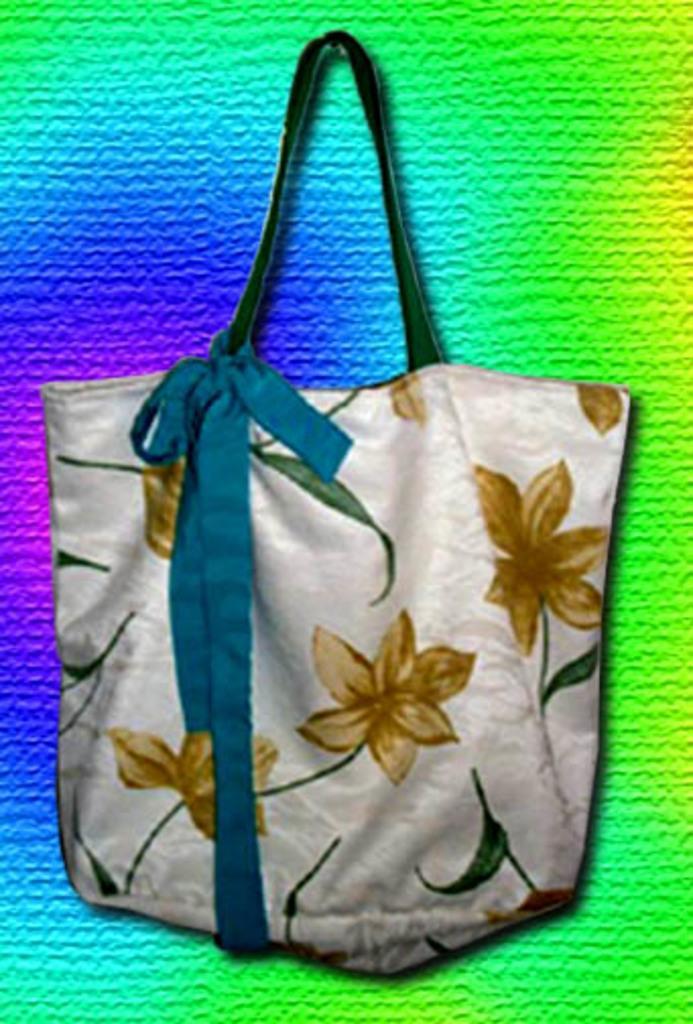Could you give a brief overview of what you see in this image? Here we can see a hand bag and behind that we can see a colorful background 